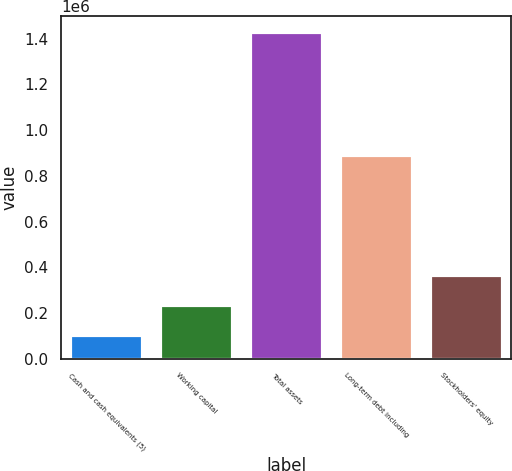<chart> <loc_0><loc_0><loc_500><loc_500><bar_chart><fcel>Cash and cash equivalents (5)<fcel>Working capital<fcel>Total assets<fcel>Long-term debt including<fcel>Stockholders' equity<nl><fcel>104221<fcel>236574<fcel>1.42775e+06<fcel>889846<fcel>368926<nl></chart> 